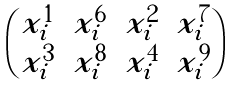Convert formula to latex. <formula><loc_0><loc_0><loc_500><loc_500>\begin{pmatrix} x _ { i } ^ { 1 } & x _ { i } ^ { 6 } & x _ { i } ^ { 2 } & x _ { i } ^ { 7 } \\ x _ { i } ^ { 3 } & x _ { i } ^ { 8 } & x _ { i } ^ { 4 } & x _ { i } ^ { 9 } \end{pmatrix}</formula> 